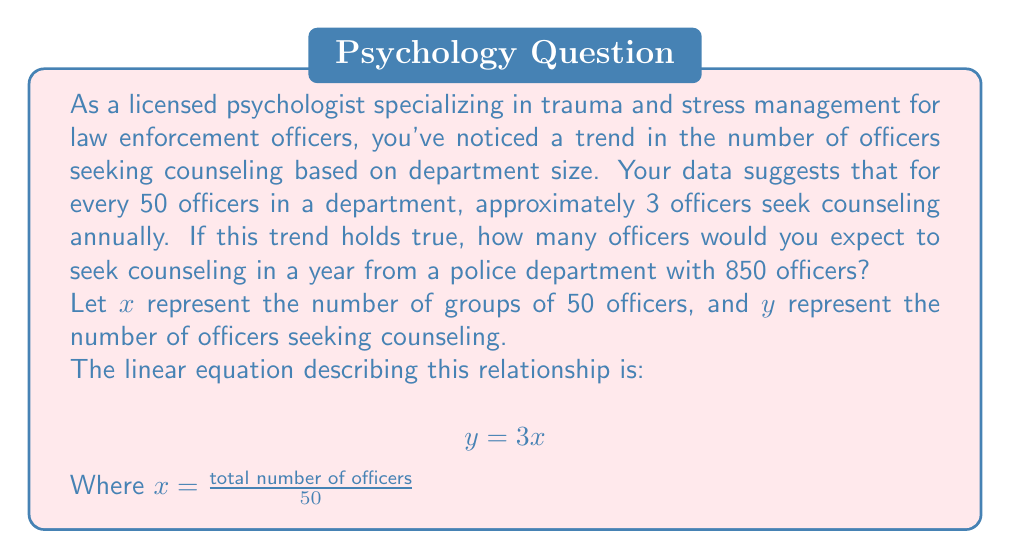Provide a solution to this math problem. To solve this problem, we'll follow these steps:

1. Calculate the value of $x$:
   $$x = \frac{\text{total number of officers}}{50} = \frac{850}{50} = 17$$

2. Substitute this value into the equation:
   $$y = 3x$$
   $$y = 3(17)$$

3. Solve for $y$:
   $$y = 51$$

This means that in a department of 850 officers, we would expect 51 officers to seek counseling in a year.

To verify, we can check that this maintains the original ratio:
$$\frac{51 \text{ seeking counseling}}{850 \text{ total officers}} \approx \frac{3}{50}$$

Which confirms our calculation is consistent with the given trend.
Answer: 51 officers 